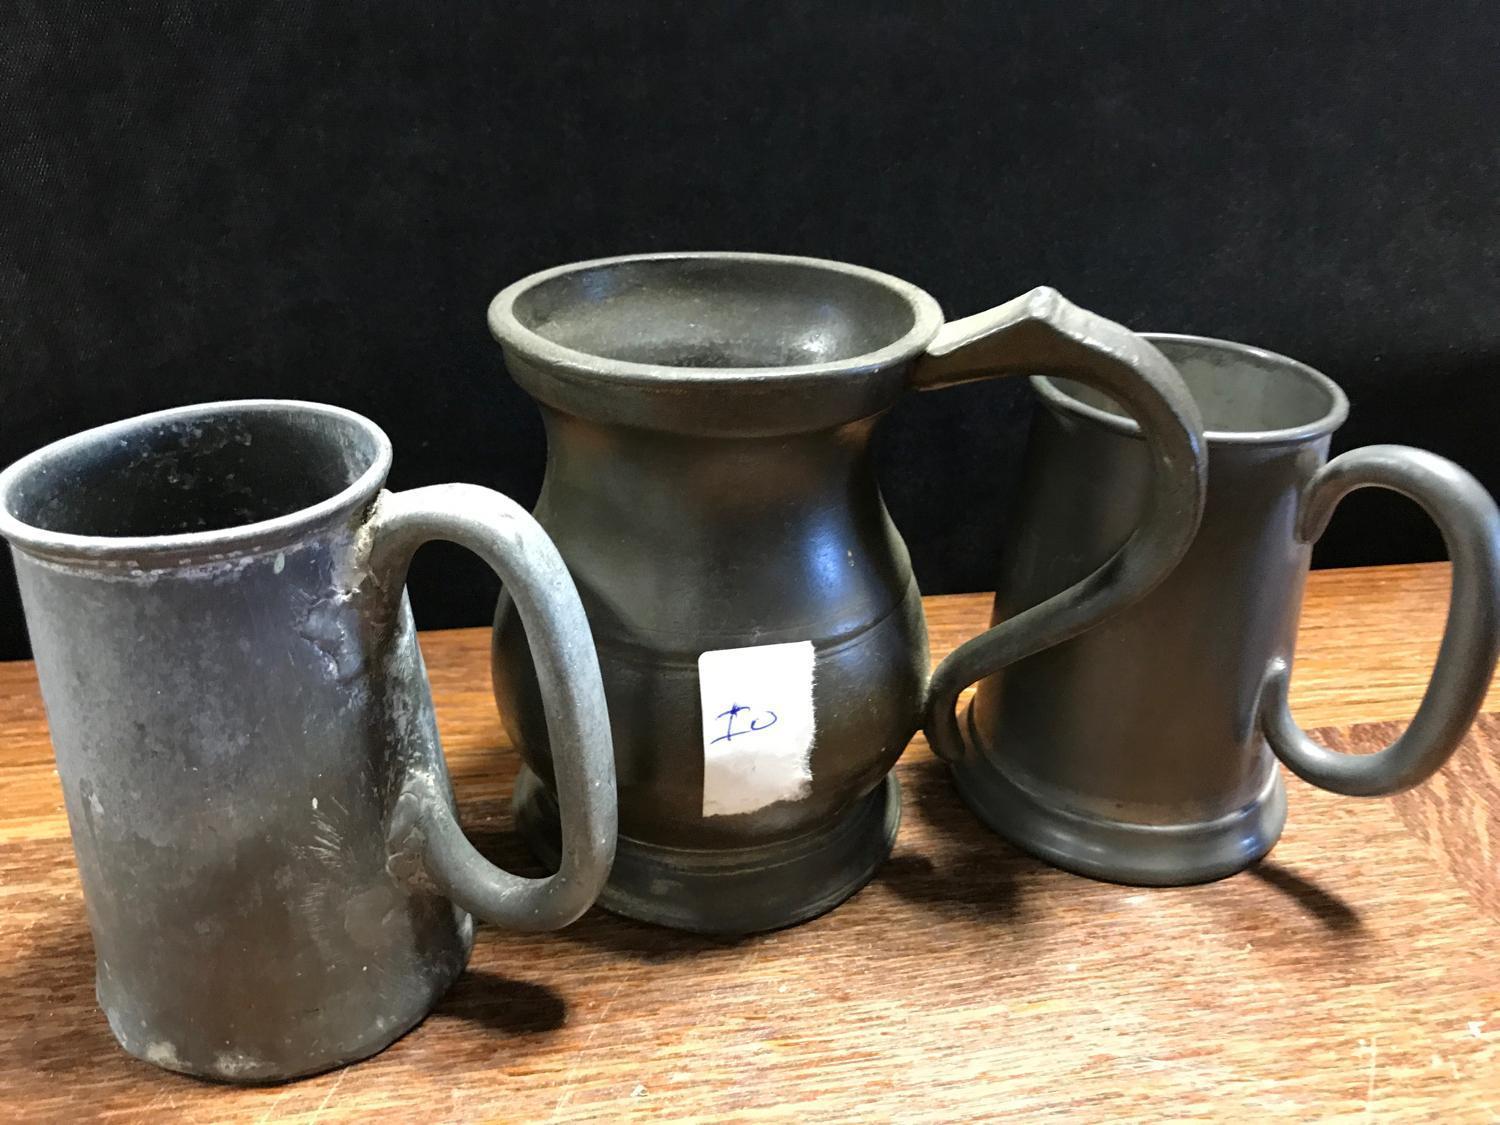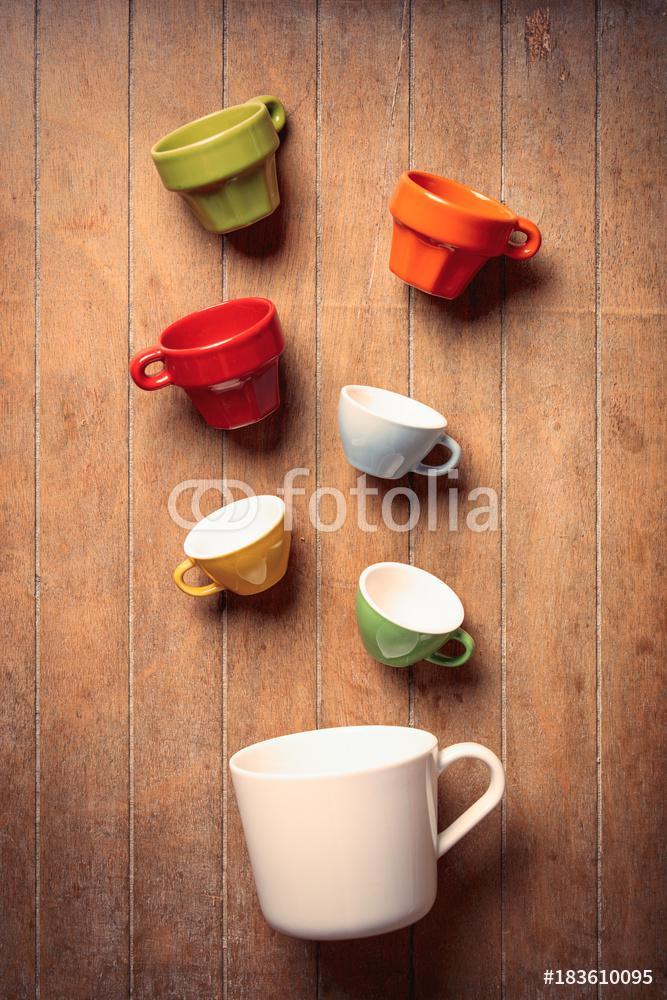The first image is the image on the left, the second image is the image on the right. Evaluate the accuracy of this statement regarding the images: "Have mugs have coffee inside them in one of the pictures.". Is it true? Answer yes or no. No. The first image is the image on the left, the second image is the image on the right. Considering the images on both sides, is "The left and right image contains a total of no more than ten cups." valid? Answer yes or no. Yes. 